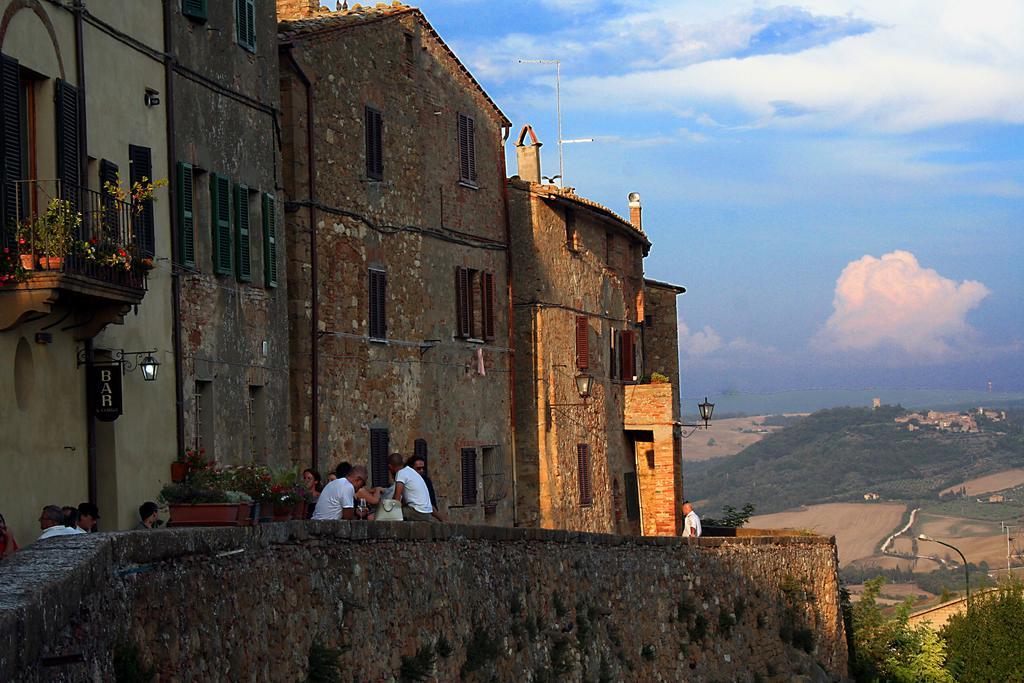Can you describe this image briefly? At the bottom of the picture, we see the wall which is made up of stones. In the middle, we see the people are standing. Beside them, we see the flower pots. On the left side, we see the people are standing. We see the flower pots and the iron railing. Beside that, we see the buildings and the lights. On the right side, we see the trees, pole and a street lights. There are trees and buildings in the background. At the top, we see the sky and the clouds. 